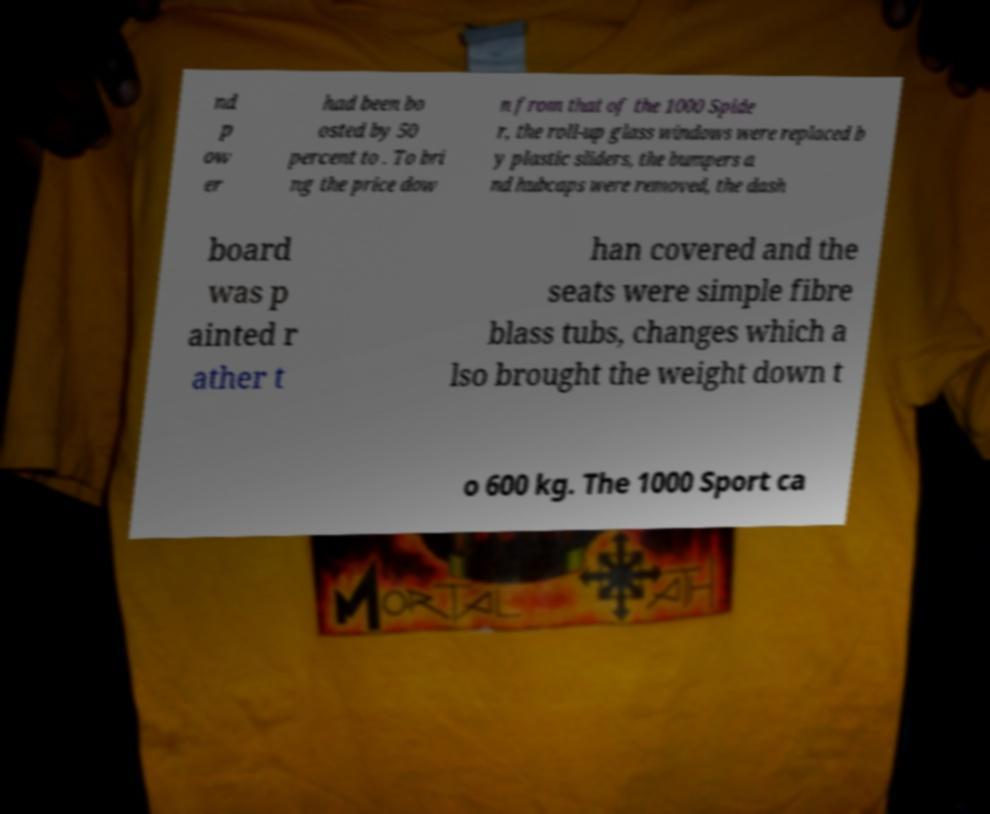Could you extract and type out the text from this image? nd p ow er had been bo osted by 50 percent to . To bri ng the price dow n from that of the 1000 Spide r, the roll-up glass windows were replaced b y plastic sliders, the bumpers a nd hubcaps were removed, the dash board was p ainted r ather t han covered and the seats were simple fibre blass tubs, changes which a lso brought the weight down t o 600 kg. The 1000 Sport ca 